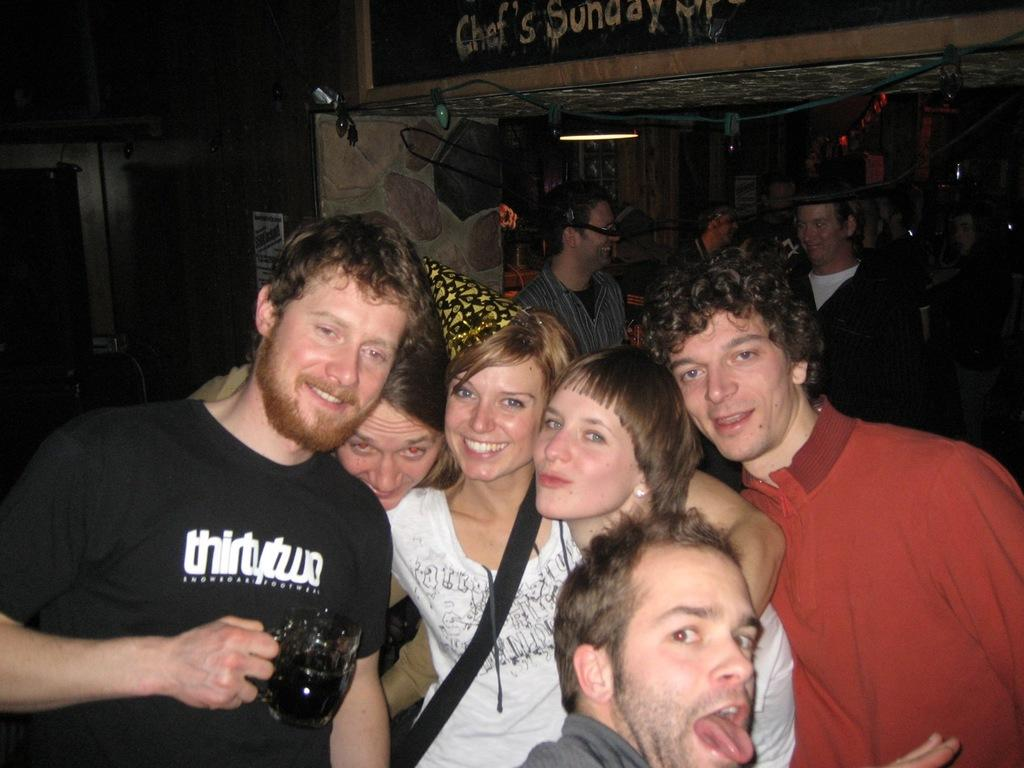<image>
Share a concise interpretation of the image provided. Group of people posing with one person wearing a shirt that says "thirtytwo". 